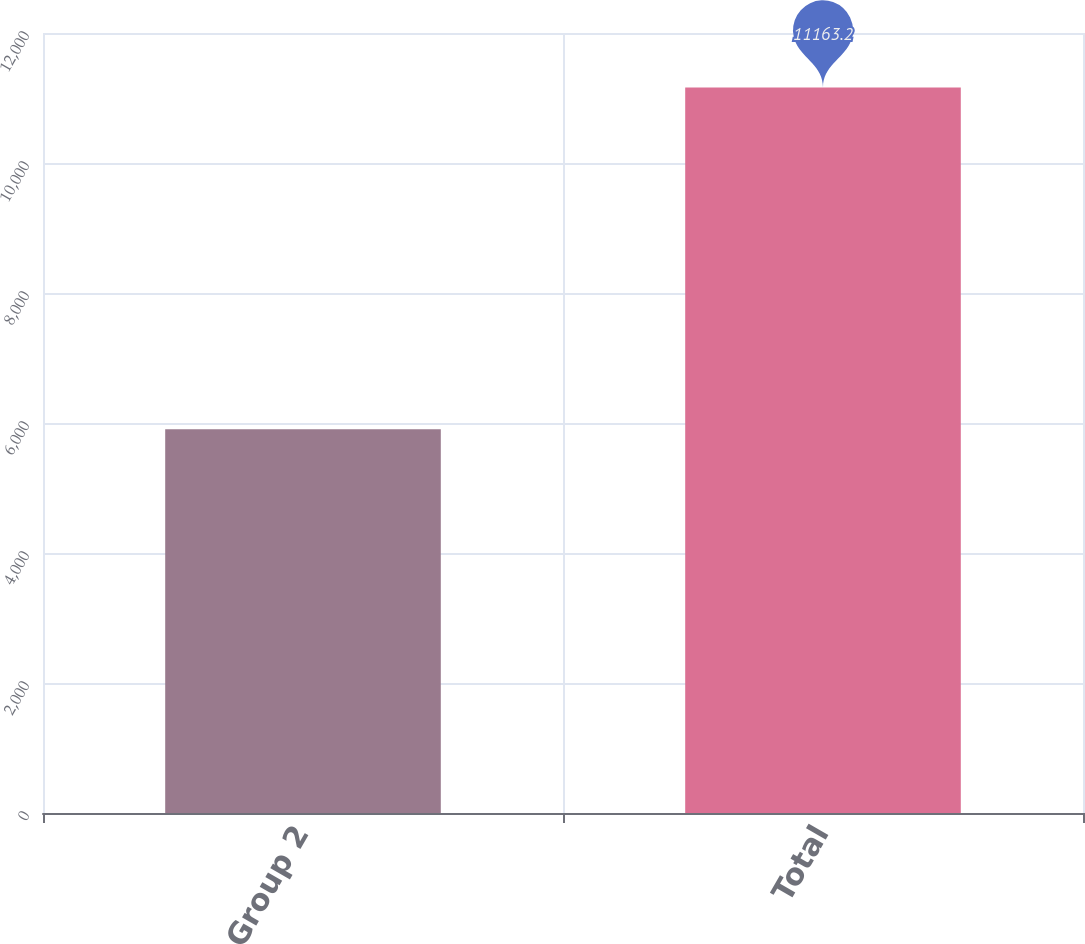Convert chart to OTSL. <chart><loc_0><loc_0><loc_500><loc_500><bar_chart><fcel>Group 2<fcel>Total<nl><fcel>5905<fcel>11163.2<nl></chart> 